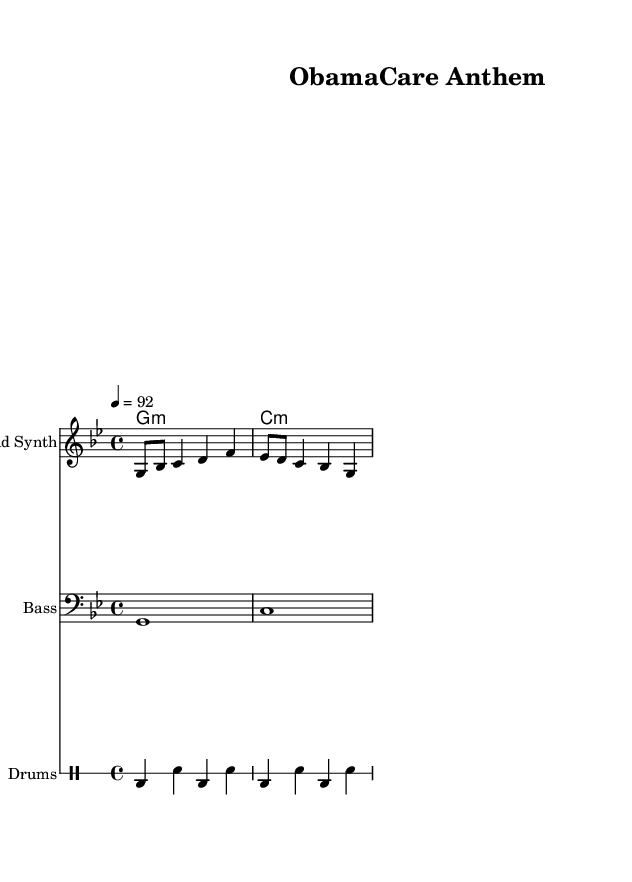what is the key signature of this music? The key signature indicates the tonality of the piece. In this score, it is labeled as G minor, which has two flats (B flat and E flat) and is reflected in the key signature at the beginning of the staff.
Answer: G minor what is the time signature of this music? The time signature is located at the beginning of the score and indicates how many beats are in each measure. Here, the time signature is 4/4, which means there are four beats per measure, and the quarter note receives one beat.
Answer: 4/4 what is the tempo of this music? The tempo is noted beneath the global section of the score. It indicates the speed at which the music should be played. In this case, it is set to 92 beats per minute.
Answer: 92 how many measures are in the melody? To find the number of measures, you can count the distinct groupings of notes separated by vertical bar lines in the melody section. In this score, there are four measures.
Answer: 4 what is the main instrument used in the melody? The main instrument specified for the melody is indicated on the staff, where it shows "Lead Synth." This denotes that the lead part is to be played using a synthesizer sound.
Answer: Lead Synth what is the purpose of drum notation in this piece? The drum notation is written in a separate staff using a simplified format to indicate rhythm. It demonstrates the percussion pattern that provides the foundational beat for the rap genre, which is crucial for maintaining the rhythmic drive and energy of the piece.
Answer: Rhythm which musical modes are applied in the harmonies section? The harmonies are stated in chord mode, where the notes are grouped to indicate the chords played to support the melody. In this piece, it features minor chords (G minor and C minor) that add mood and depth to the overall composition.
Answer: Minor chords 